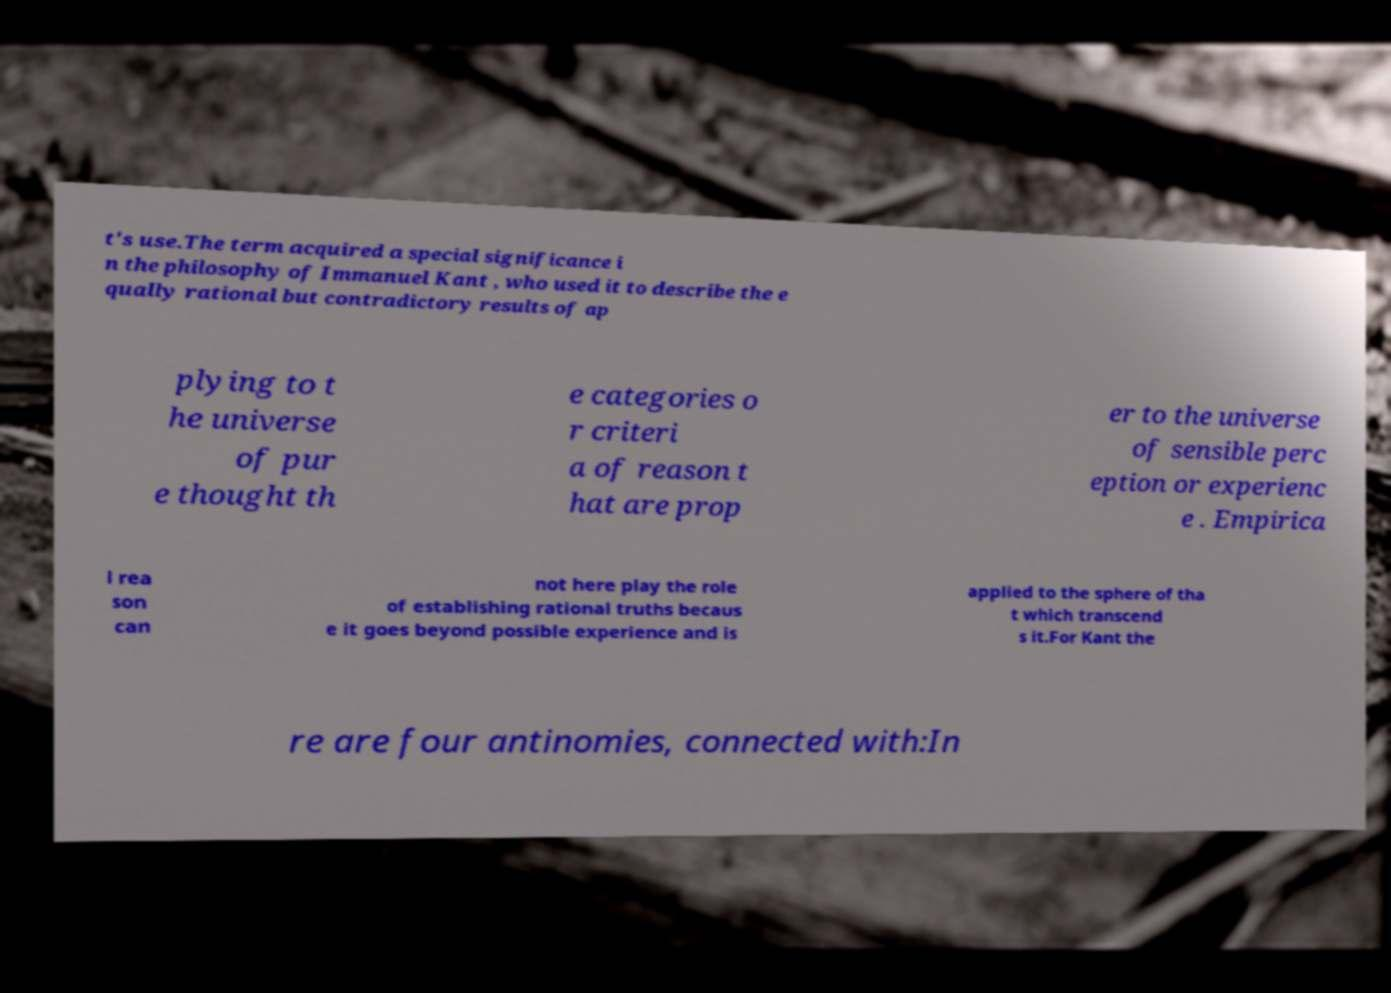Please read and relay the text visible in this image. What does it say? t's use.The term acquired a special significance i n the philosophy of Immanuel Kant , who used it to describe the e qually rational but contradictory results of ap plying to t he universe of pur e thought th e categories o r criteri a of reason t hat are prop er to the universe of sensible perc eption or experienc e . Empirica l rea son can not here play the role of establishing rational truths becaus e it goes beyond possible experience and is applied to the sphere of tha t which transcend s it.For Kant the re are four antinomies, connected with:In 